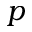Convert formula to latex. <formula><loc_0><loc_0><loc_500><loc_500>p</formula> 